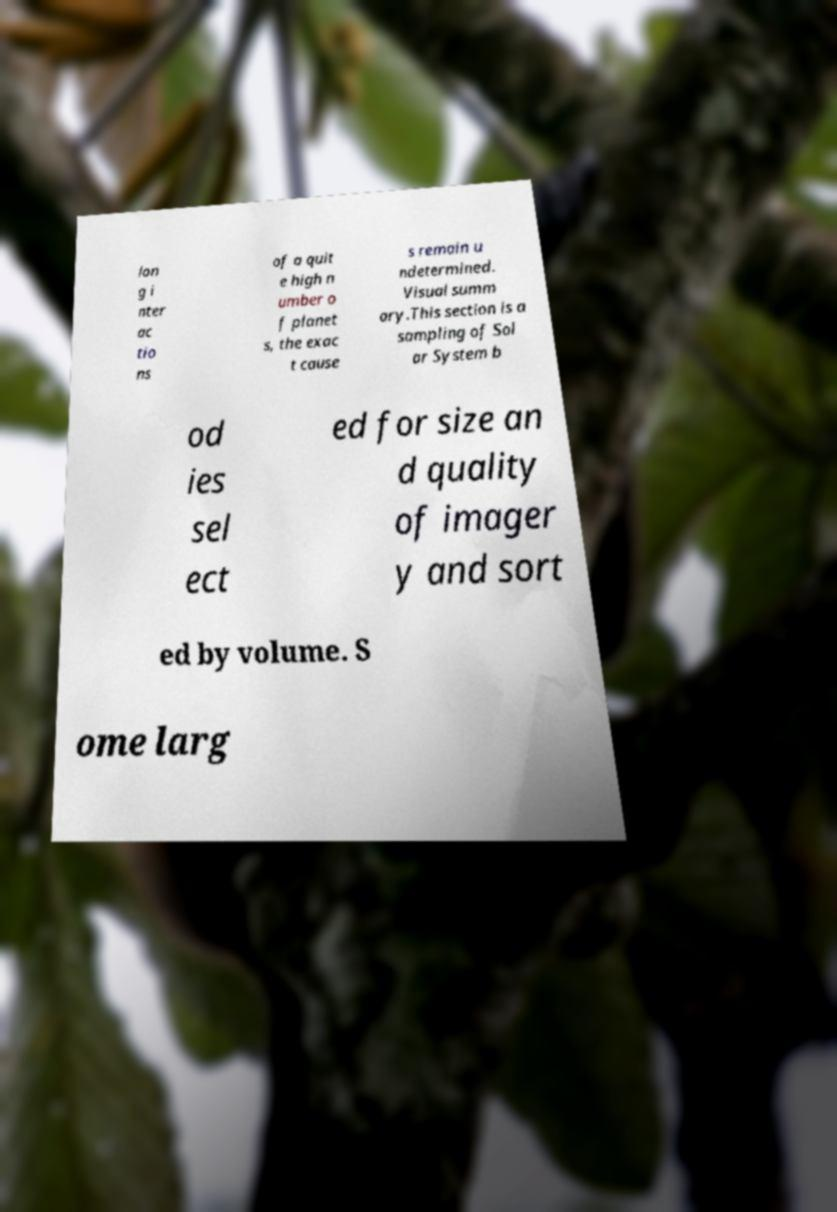I need the written content from this picture converted into text. Can you do that? lon g i nter ac tio ns of a quit e high n umber o f planet s, the exac t cause s remain u ndetermined. Visual summ ary.This section is a sampling of Sol ar System b od ies sel ect ed for size an d quality of imager y and sort ed by volume. S ome larg 